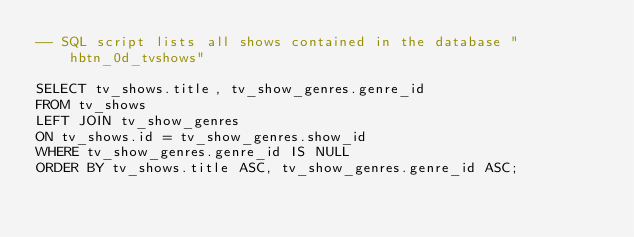Convert code to text. <code><loc_0><loc_0><loc_500><loc_500><_SQL_>-- SQL script lists all shows contained in the database "hbtn_0d_tvshows"

SELECT tv_shows.title, tv_show_genres.genre_id
FROM tv_shows
LEFT JOIN tv_show_genres
ON tv_shows.id = tv_show_genres.show_id
WHERE tv_show_genres.genre_id IS NULL
ORDER BY tv_shows.title ASC, tv_show_genres.genre_id ASC;
</code> 